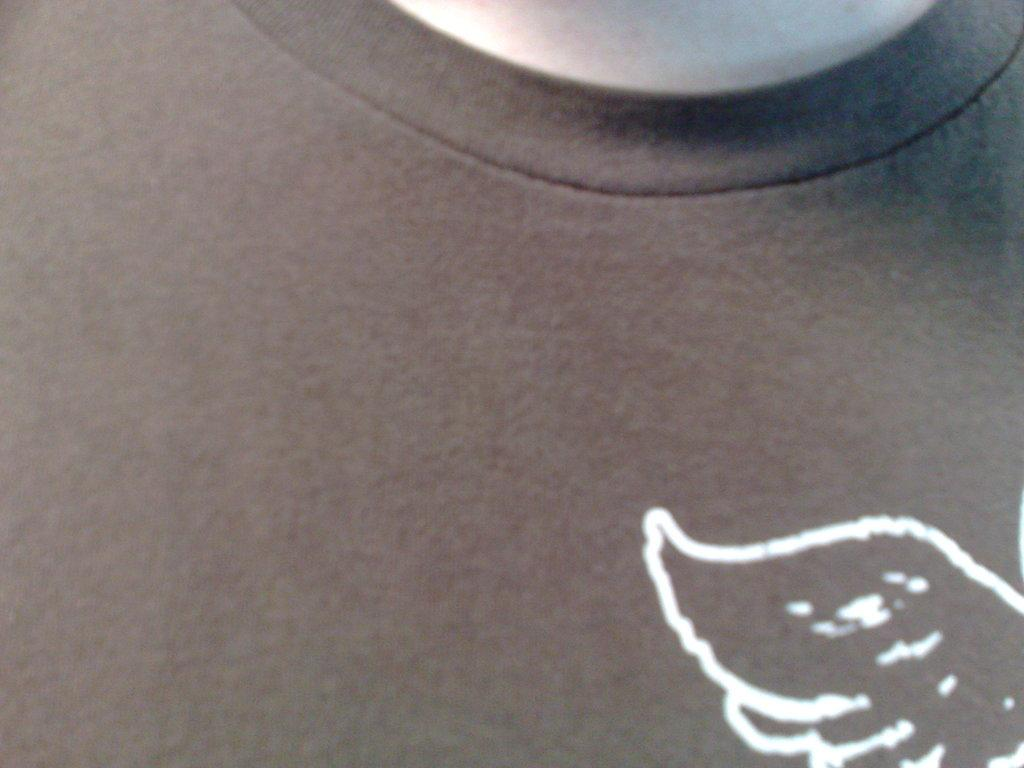What is the main subject of the image? The main subject of the image is a painting. What color is the painting? The painting is in white color. What does the painting depict? The painting depicts an object. What type of ear is shown in the painting? There is no ear depicted in the painting; it only depicts an object. How does the painting react to the viewer's presence? The painting is an inanimate object and does not react to the viewer's presence. 